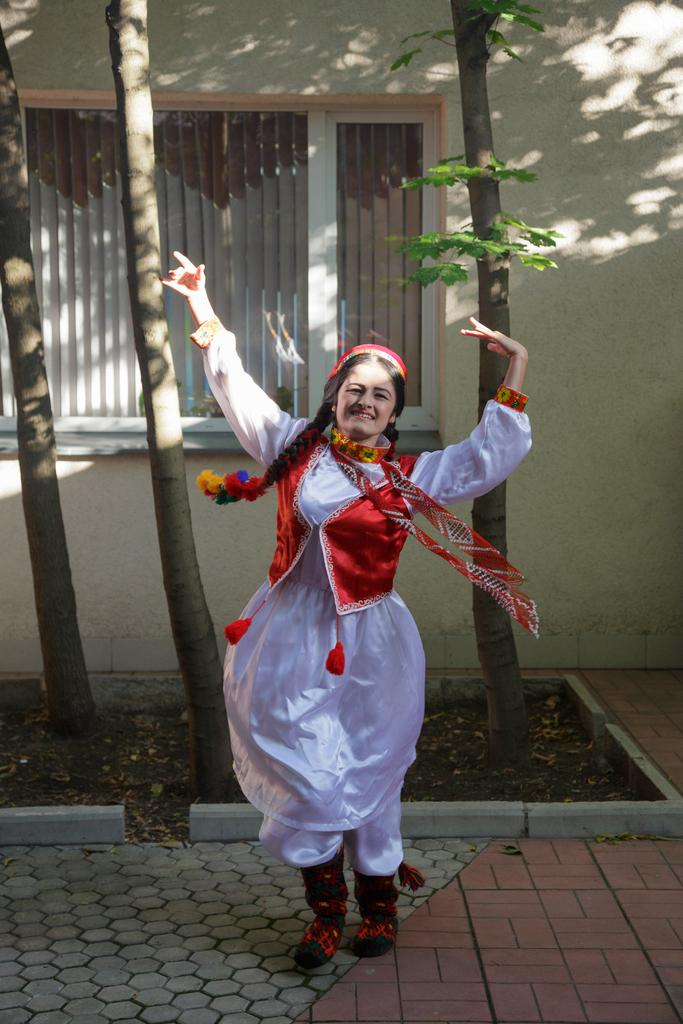Who is present in the image? There is a woman in the image. What is the woman doing in the image? The woman is standing on the ground and smiling. What can be seen in the background of the image? There is a window and a wall in the background of the image. What type of surface is visible beneath the woman's feet? Soil is visible in the image. What structures are present in the image? There are poles in the image. How many planes are visible in the image? There are no planes visible in the image. What type of chairs can be seen in the image? There are no chairs present in the image. 